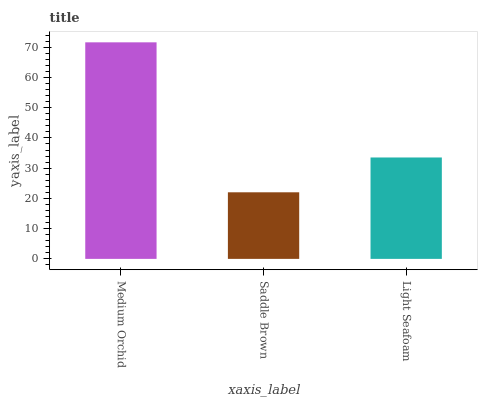Is Saddle Brown the minimum?
Answer yes or no. Yes. Is Medium Orchid the maximum?
Answer yes or no. Yes. Is Light Seafoam the minimum?
Answer yes or no. No. Is Light Seafoam the maximum?
Answer yes or no. No. Is Light Seafoam greater than Saddle Brown?
Answer yes or no. Yes. Is Saddle Brown less than Light Seafoam?
Answer yes or no. Yes. Is Saddle Brown greater than Light Seafoam?
Answer yes or no. No. Is Light Seafoam less than Saddle Brown?
Answer yes or no. No. Is Light Seafoam the high median?
Answer yes or no. Yes. Is Light Seafoam the low median?
Answer yes or no. Yes. Is Saddle Brown the high median?
Answer yes or no. No. Is Saddle Brown the low median?
Answer yes or no. No. 